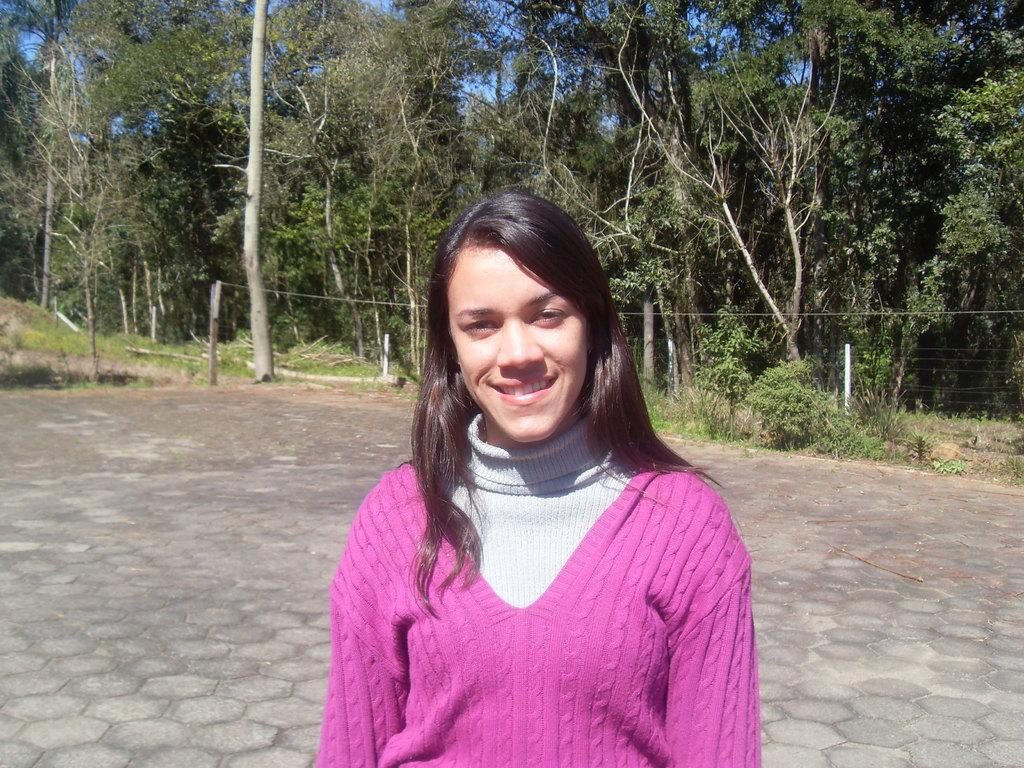What is the woman in the image doing? The woman is standing in the image. What expression does the woman have? The woman is smiling. What can be seen in the background of the image? There are plants and trees in the background of the image. What type of note is the woman holding in the image? There is no note visible in the image. What type of honey is being produced by the plants in the image? The image does not show any honey production by the plants. 